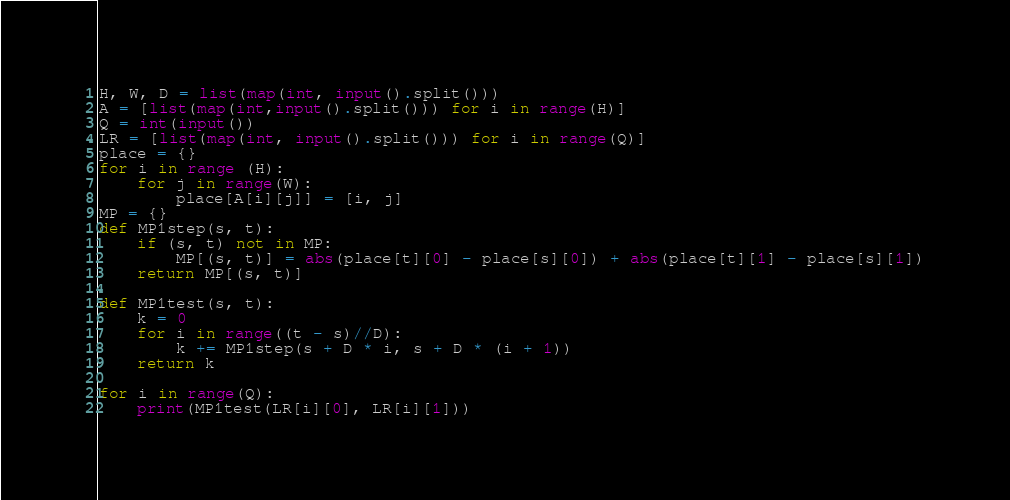Convert code to text. <code><loc_0><loc_0><loc_500><loc_500><_Python_>H, W, D = list(map(int, input().split()))
A = [list(map(int,input().split())) for i in range(H)]
Q = int(input())
LR = [list(map(int, input().split())) for i in range(Q)]
place = {}
for i in range (H):
	for j in range(W):
		place[A[i][j]] = [i, j]
MP = {}
def MP1step(s, t):
	if (s, t) not in MP:
		MP[(s, t)] = abs(place[t][0] - place[s][0]) + abs(place[t][1] - place[s][1])
	return MP[(s, t)]

def MP1test(s, t):
	k = 0
	for i in range((t - s)//D):
		k += MP1step(s + D * i, s + D * (i + 1))
	return k

for i in range(Q):
	print(MP1test(LR[i][0], LR[i][1]))</code> 